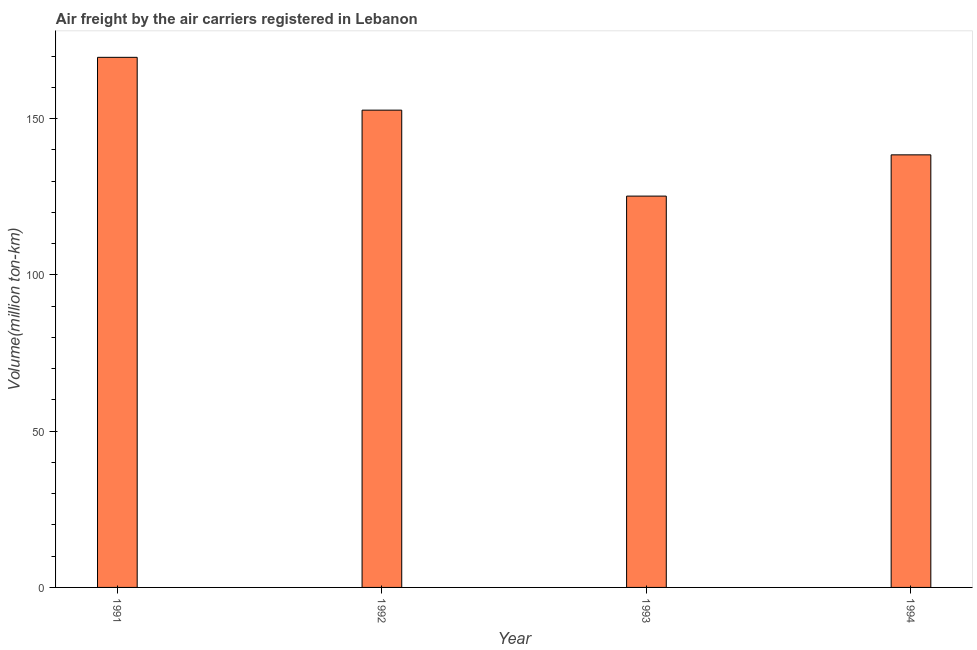What is the title of the graph?
Give a very brief answer. Air freight by the air carriers registered in Lebanon. What is the label or title of the X-axis?
Give a very brief answer. Year. What is the label or title of the Y-axis?
Give a very brief answer. Volume(million ton-km). What is the air freight in 1993?
Your response must be concise. 125.2. Across all years, what is the maximum air freight?
Provide a succinct answer. 169.6. Across all years, what is the minimum air freight?
Offer a very short reply. 125.2. In which year was the air freight minimum?
Offer a very short reply. 1993. What is the sum of the air freight?
Provide a succinct answer. 585.9. What is the difference between the air freight in 1991 and 1994?
Ensure brevity in your answer.  31.2. What is the average air freight per year?
Offer a very short reply. 146.47. What is the median air freight?
Give a very brief answer. 145.55. What is the ratio of the air freight in 1991 to that in 1994?
Your answer should be very brief. 1.23. Is the air freight in 1991 less than that in 1994?
Give a very brief answer. No. What is the difference between the highest and the second highest air freight?
Make the answer very short. 16.9. What is the difference between the highest and the lowest air freight?
Give a very brief answer. 44.4. How many bars are there?
Keep it short and to the point. 4. Are all the bars in the graph horizontal?
Provide a short and direct response. No. How many years are there in the graph?
Your answer should be very brief. 4. What is the difference between two consecutive major ticks on the Y-axis?
Your answer should be very brief. 50. Are the values on the major ticks of Y-axis written in scientific E-notation?
Your response must be concise. No. What is the Volume(million ton-km) of 1991?
Offer a very short reply. 169.6. What is the Volume(million ton-km) in 1992?
Your answer should be compact. 152.7. What is the Volume(million ton-km) in 1993?
Provide a short and direct response. 125.2. What is the Volume(million ton-km) in 1994?
Offer a terse response. 138.4. What is the difference between the Volume(million ton-km) in 1991 and 1992?
Offer a terse response. 16.9. What is the difference between the Volume(million ton-km) in 1991 and 1993?
Give a very brief answer. 44.4. What is the difference between the Volume(million ton-km) in 1991 and 1994?
Give a very brief answer. 31.2. What is the ratio of the Volume(million ton-km) in 1991 to that in 1992?
Provide a short and direct response. 1.11. What is the ratio of the Volume(million ton-km) in 1991 to that in 1993?
Give a very brief answer. 1.35. What is the ratio of the Volume(million ton-km) in 1991 to that in 1994?
Your response must be concise. 1.23. What is the ratio of the Volume(million ton-km) in 1992 to that in 1993?
Keep it short and to the point. 1.22. What is the ratio of the Volume(million ton-km) in 1992 to that in 1994?
Provide a short and direct response. 1.1. What is the ratio of the Volume(million ton-km) in 1993 to that in 1994?
Your answer should be compact. 0.91. 